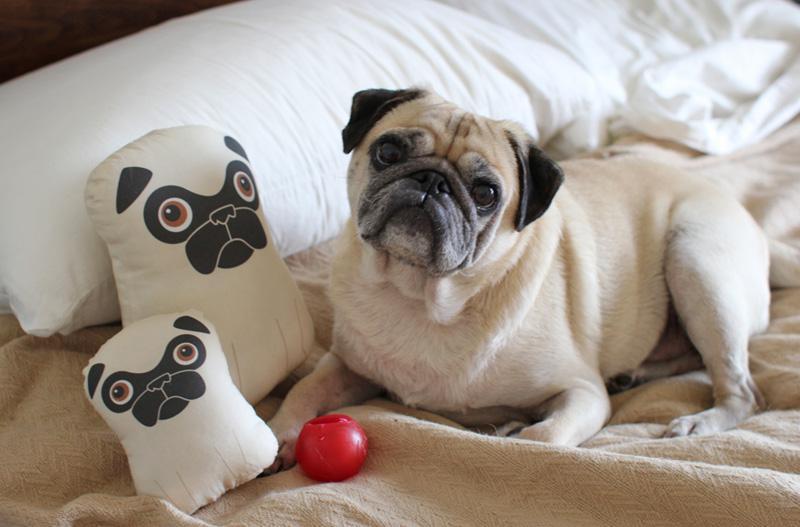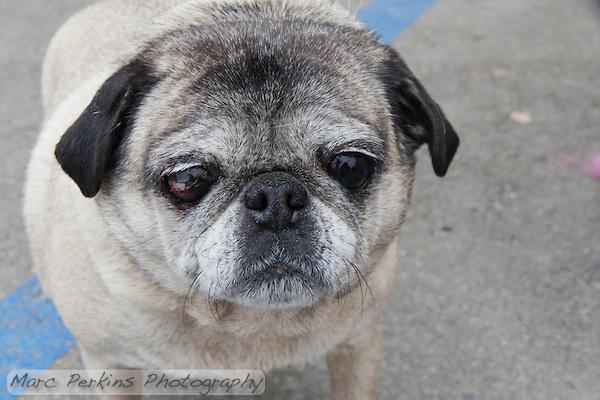The first image is the image on the left, the second image is the image on the right. Examine the images to the left and right. Is the description "Each image in the pair has two pugs touching each other." accurate? Answer yes or no. No. The first image is the image on the left, the second image is the image on the right. For the images shown, is this caption "There is exactly one pug in at least one image." true? Answer yes or no. Yes. 